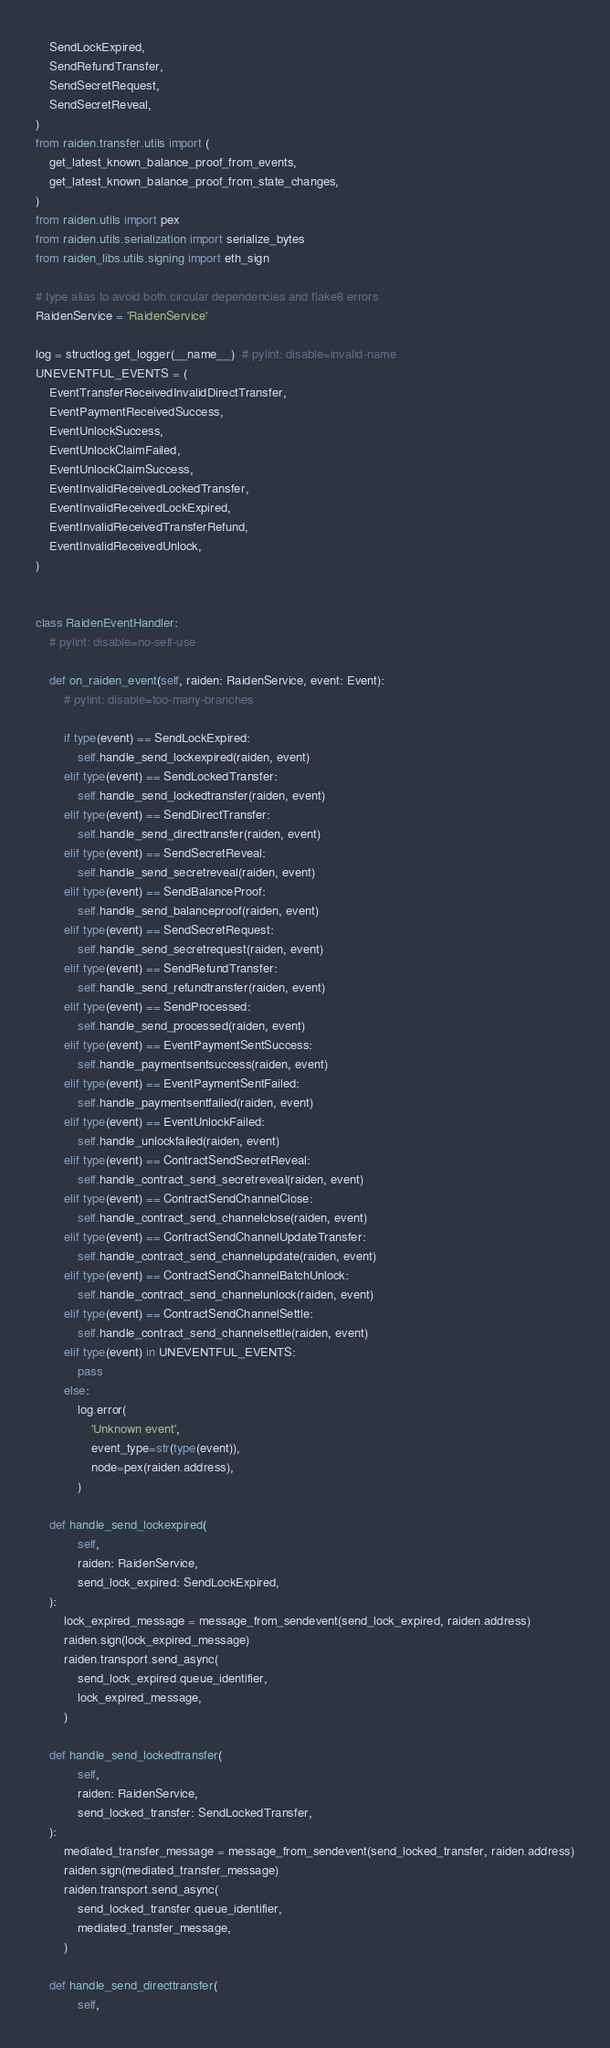Convert code to text. <code><loc_0><loc_0><loc_500><loc_500><_Python_>    SendLockExpired,
    SendRefundTransfer,
    SendSecretRequest,
    SendSecretReveal,
)
from raiden.transfer.utils import (
    get_latest_known_balance_proof_from_events,
    get_latest_known_balance_proof_from_state_changes,
)
from raiden.utils import pex
from raiden.utils.serialization import serialize_bytes
from raiden_libs.utils.signing import eth_sign

# type alias to avoid both circular dependencies and flake8 errors
RaidenService = 'RaidenService'

log = structlog.get_logger(__name__)  # pylint: disable=invalid-name
UNEVENTFUL_EVENTS = (
    EventTransferReceivedInvalidDirectTransfer,
    EventPaymentReceivedSuccess,
    EventUnlockSuccess,
    EventUnlockClaimFailed,
    EventUnlockClaimSuccess,
    EventInvalidReceivedLockedTransfer,
    EventInvalidReceivedLockExpired,
    EventInvalidReceivedTransferRefund,
    EventInvalidReceivedUnlock,
)


class RaidenEventHandler:
    # pylint: disable=no-self-use

    def on_raiden_event(self, raiden: RaidenService, event: Event):
        # pylint: disable=too-many-branches

        if type(event) == SendLockExpired:
            self.handle_send_lockexpired(raiden, event)
        elif type(event) == SendLockedTransfer:
            self.handle_send_lockedtransfer(raiden, event)
        elif type(event) == SendDirectTransfer:
            self.handle_send_directtransfer(raiden, event)
        elif type(event) == SendSecretReveal:
            self.handle_send_secretreveal(raiden, event)
        elif type(event) == SendBalanceProof:
            self.handle_send_balanceproof(raiden, event)
        elif type(event) == SendSecretRequest:
            self.handle_send_secretrequest(raiden, event)
        elif type(event) == SendRefundTransfer:
            self.handle_send_refundtransfer(raiden, event)
        elif type(event) == SendProcessed:
            self.handle_send_processed(raiden, event)
        elif type(event) == EventPaymentSentSuccess:
            self.handle_paymentsentsuccess(raiden, event)
        elif type(event) == EventPaymentSentFailed:
            self.handle_paymentsentfailed(raiden, event)
        elif type(event) == EventUnlockFailed:
            self.handle_unlockfailed(raiden, event)
        elif type(event) == ContractSendSecretReveal:
            self.handle_contract_send_secretreveal(raiden, event)
        elif type(event) == ContractSendChannelClose:
            self.handle_contract_send_channelclose(raiden, event)
        elif type(event) == ContractSendChannelUpdateTransfer:
            self.handle_contract_send_channelupdate(raiden, event)
        elif type(event) == ContractSendChannelBatchUnlock:
            self.handle_contract_send_channelunlock(raiden, event)
        elif type(event) == ContractSendChannelSettle:
            self.handle_contract_send_channelsettle(raiden, event)
        elif type(event) in UNEVENTFUL_EVENTS:
            pass
        else:
            log.error(
                'Unknown event',
                event_type=str(type(event)),
                node=pex(raiden.address),
            )

    def handle_send_lockexpired(
            self,
            raiden: RaidenService,
            send_lock_expired: SendLockExpired,
    ):
        lock_expired_message = message_from_sendevent(send_lock_expired, raiden.address)
        raiden.sign(lock_expired_message)
        raiden.transport.send_async(
            send_lock_expired.queue_identifier,
            lock_expired_message,
        )

    def handle_send_lockedtransfer(
            self,
            raiden: RaidenService,
            send_locked_transfer: SendLockedTransfer,
    ):
        mediated_transfer_message = message_from_sendevent(send_locked_transfer, raiden.address)
        raiden.sign(mediated_transfer_message)
        raiden.transport.send_async(
            send_locked_transfer.queue_identifier,
            mediated_transfer_message,
        )

    def handle_send_directtransfer(
            self,</code> 